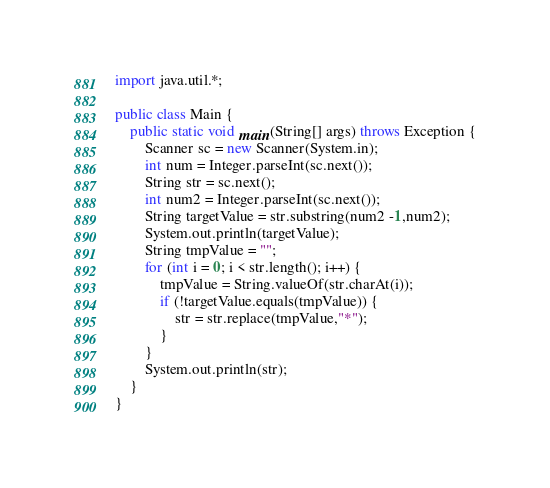<code> <loc_0><loc_0><loc_500><loc_500><_Java_>import java.util.*;

public class Main {
    public static void main(String[] args) throws Exception {
        Scanner sc = new Scanner(System.in);
        int num = Integer.parseInt(sc.next());
        String str = sc.next();
        int num2 = Integer.parseInt(sc.next());
        String targetValue = str.substring(num2 -1,num2);
        System.out.println(targetValue);
        String tmpValue = "";
        for (int i = 0; i < str.length(); i++) {
            tmpValue = String.valueOf(str.charAt(i));
            if (!targetValue.equals(tmpValue)) {
                str = str.replace(tmpValue,"*");
            }
        }
        System.out.println(str);
    }
}</code> 